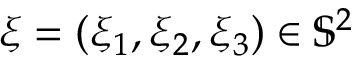<formula> <loc_0><loc_0><loc_500><loc_500>\xi = ( \xi _ { 1 } , \xi _ { 2 } , \xi _ { 3 } ) \in \mathbb { S } ^ { 2 }</formula> 